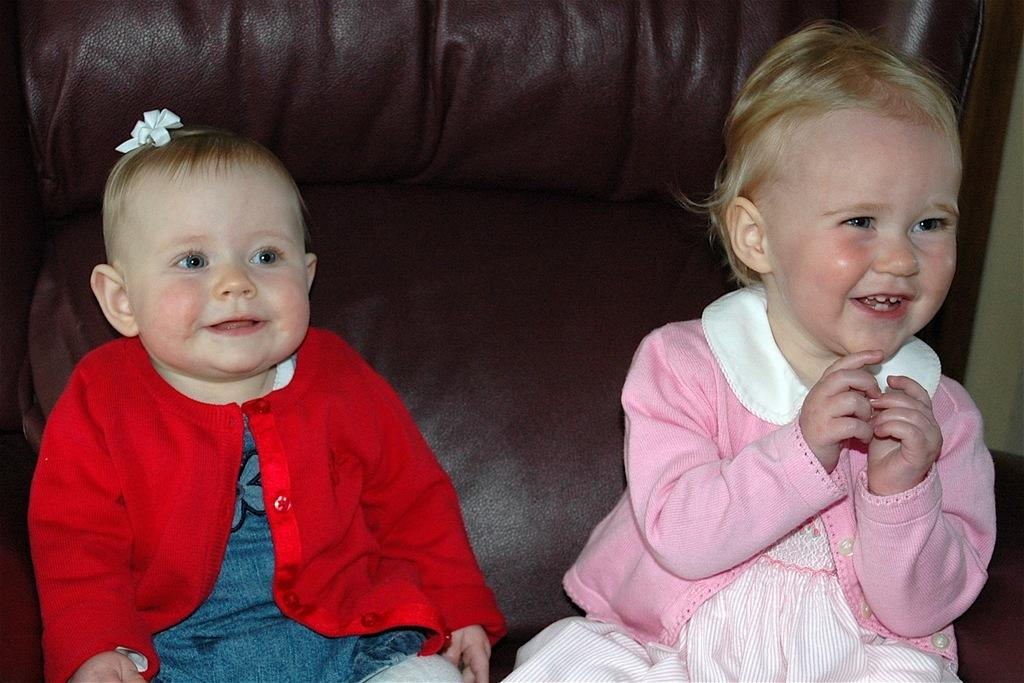Who is present in the image? There are children in the image. What expression do the children have? The children have smiling faces. What can be seen in the background of the image? There is a sofa in the background of the image. What type of advertisement is displayed on the legs of the children in the image? There are no advertisements or legs visible in the image; it features children with smiling faces and a background with a sofa. 